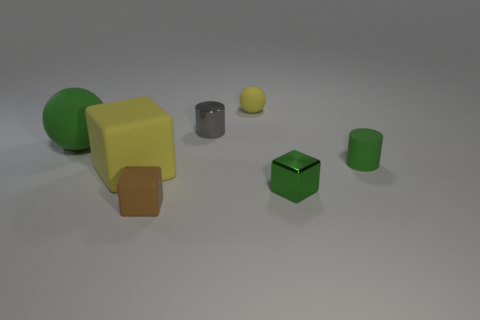Subtract all tiny blocks. How many blocks are left? 1 Subtract all gray cylinders. How many cylinders are left? 1 Subtract all cylinders. How many objects are left? 5 Add 3 blocks. How many objects exist? 10 Subtract 1 cylinders. How many cylinders are left? 1 Subtract all yellow cylinders. How many green spheres are left? 1 Subtract all large things. Subtract all large blue shiny balls. How many objects are left? 5 Add 7 big green things. How many big green things are left? 8 Add 7 small gray rubber spheres. How many small gray rubber spheres exist? 7 Subtract 1 yellow blocks. How many objects are left? 6 